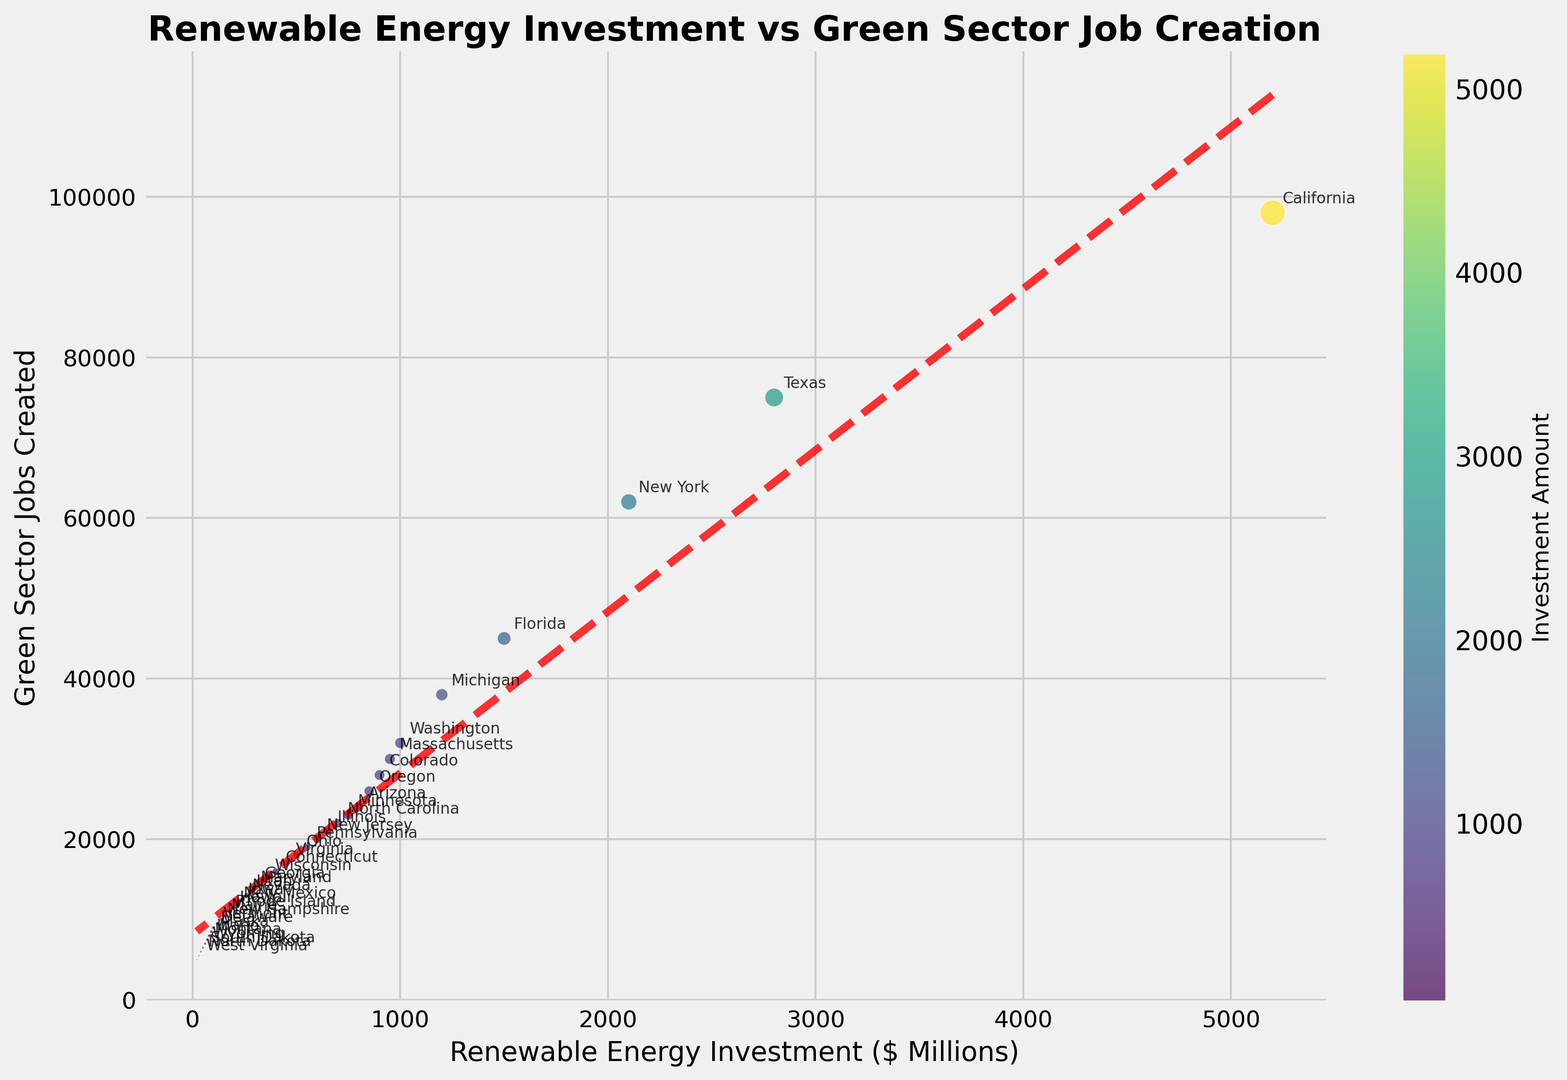Which state has the highest renewable energy investment? By examining the scatter plot, we can identify the point with the highest x-coordinate, which corresponds to the largest renewable energy investment amount. The state with the highest investment is labeled as California.
Answer: California What is the trend shown by the dashed line on the scatter plot? The dashed line is a polynomial trend line fitted to the data points. It shows a positive correlation between renewable energy investment and green sector jobs created, indicating that as investment increases, the number of jobs created also tends to increase.
Answer: Positive Correlation What is the average number of green sector jobs created for states with renewable energy investments above $1 billion? From the scatter plot, identify the states with investments above $1 billion. Calculate the average number of green sector jobs for these states. These states are California, Texas, New York, Florida, and Michigan. Their job counts are 98000, 75000, 62000, 45000, and 38000 respectively. The average is (98000 + 75000 + 62000 + 45000 + 38000) / 5 = 63600.
Answer: 63600 Does every state with higher than $500 million investments create more than 18000 green sector jobs? Identify the states with investments higher than $500 million (California, Texas, New York, Florida, Michigan, Washington, Massachusetts, and Colorado). Check if the number of jobs is greater than 18000 for each of these states, which it is.
Answer: Yes Which states create less than 15000 green sector jobs but have investments of more than $200 million? Locate the points where investments are more than $200 million but jobs created are less than 15000. The states that satisfy these conditions are Maryland, Utah, and Nevada.
Answer: Maryland, Utah, Nevada Are there any states with investment levels below $50 million? Check the scatter plot for points with x-values below 50 million. The states identified are Wyoming, South Dakota, North Dakota, and West Virginia.
Answer: Wyoming, South Dakota, North Dakota, West Virginia What color represents the states with the highest renewable energy investments? The color of the points represents the investment amount, with a color gradient from lower to higher investment. By examining the scatter plot, the states with the highest investments (California, Texas) are represented by shades of yellow.
Answer: Yellow What's the typical size of markers for states with investment around $400 million? Identify the points around the $400 million investment mark and observe their marker size. States in this range, like Connecticut, have a marker size that is medium-sized compared to others, which likely indicates a proportional relationship of marker size to investment amount.
Answer: Medium-sized What correlation does the color bar represent? The color bar indicates that the color of each point on the scatter plot corresponds to the investment amount in millions. Darker colors represent lower investments, and brighter colors represent higher investments.
Answer: Investment Amount Which state has the smallest number of green sector jobs created and how does its investment compare? Identify the point with the lowest y-coordinate, labeled West Virginia, creating 5000 jobs. Its corresponding x-coordinate shows an investment of $20 million, among the lowest investments in the plot.
Answer: West Virginia, $20 million 